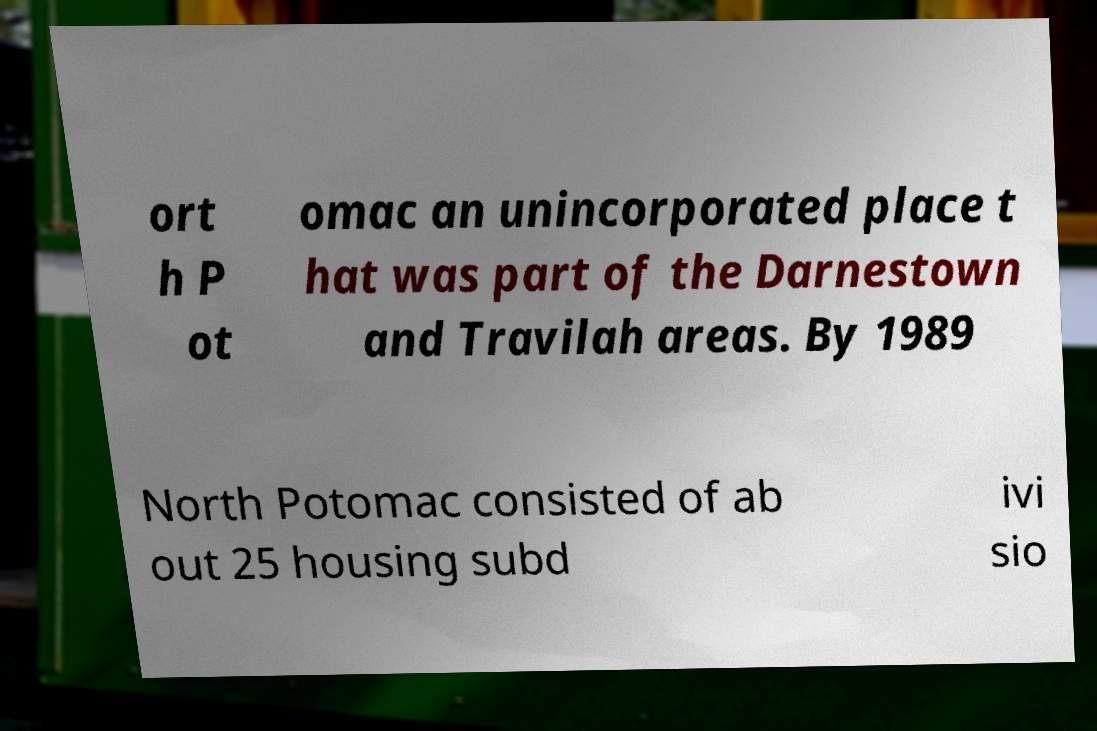Can you read and provide the text displayed in the image?This photo seems to have some interesting text. Can you extract and type it out for me? ort h P ot omac an unincorporated place t hat was part of the Darnestown and Travilah areas. By 1989 North Potomac consisted of ab out 25 housing subd ivi sio 